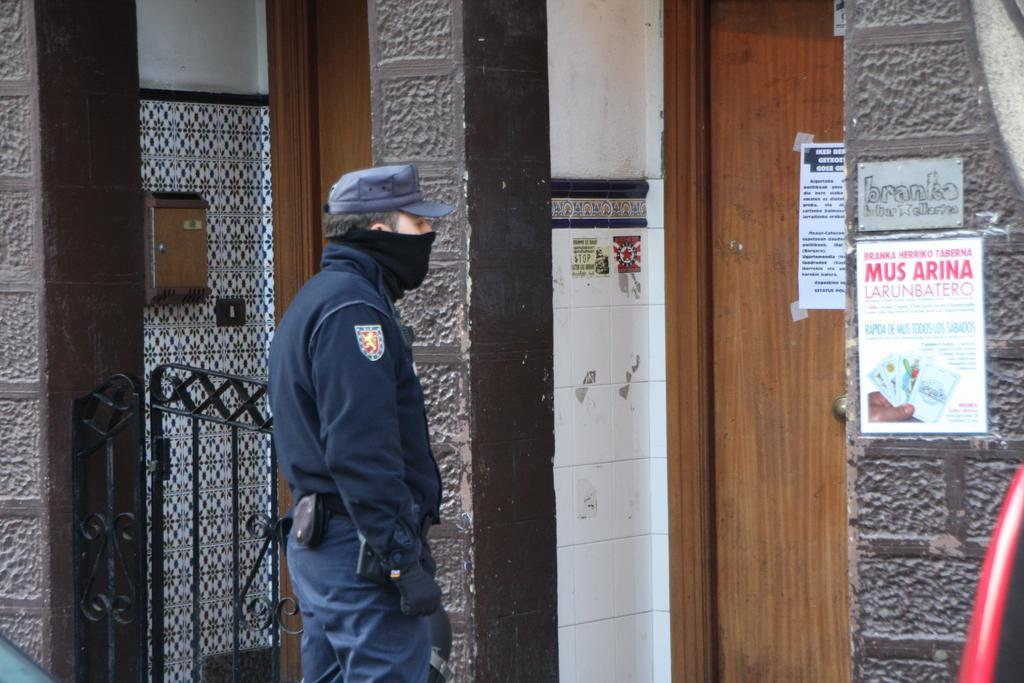What is on the wall and door in the image? There are posters on the wall and door in the image. What can be seen in the image that might serve as an entrance or exit? There is a gate in the image. Can you describe the person in the image? The person in the image is standing and wearing a cap. What is attached to the tile wall in the image? There is a box attached to a tile wall in the image. How much celery is being used to write on the posters in the image? There is no celery present in the image, and it is not being used to write on the posters. How many pieces of chalk are visible in the image? There is no chalk visible in the image. 